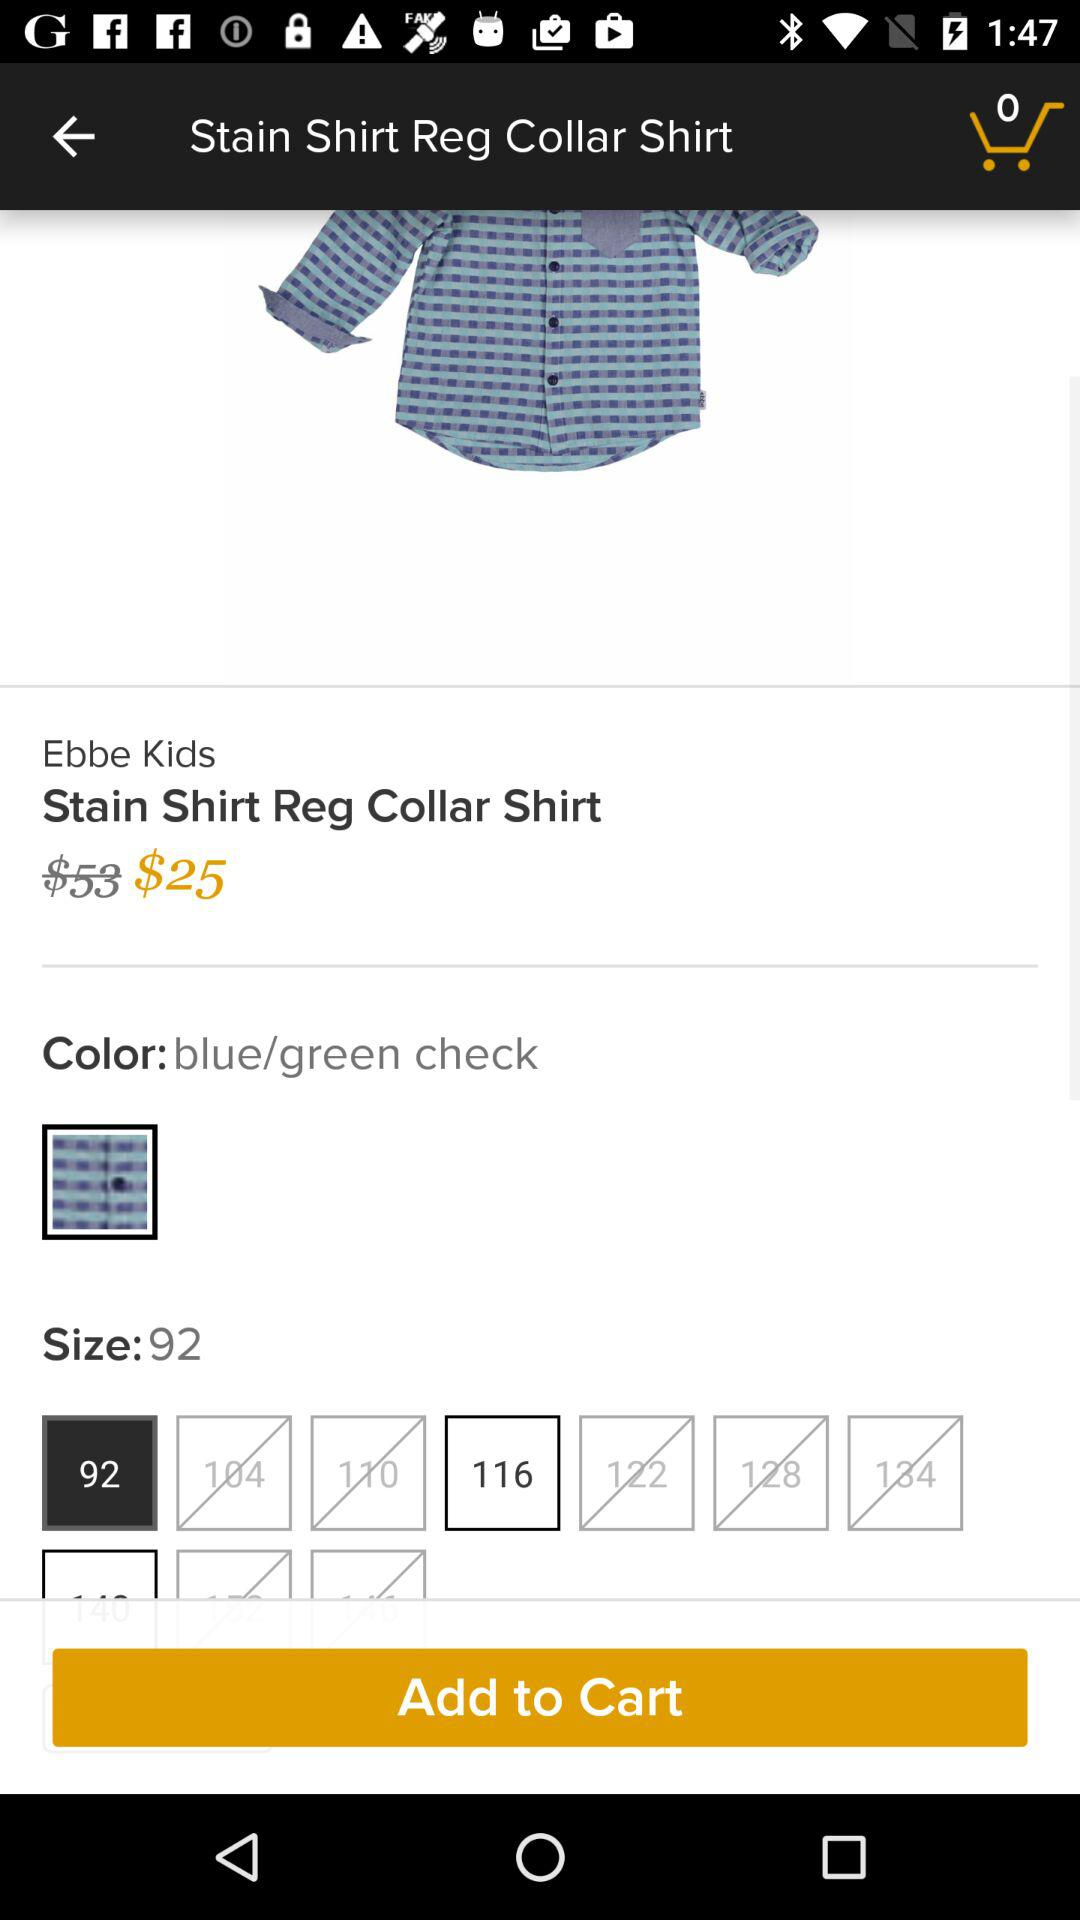What size is selected? The selected size is 92. 